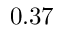Convert formula to latex. <formula><loc_0><loc_0><loc_500><loc_500>0 . 3 7</formula> 